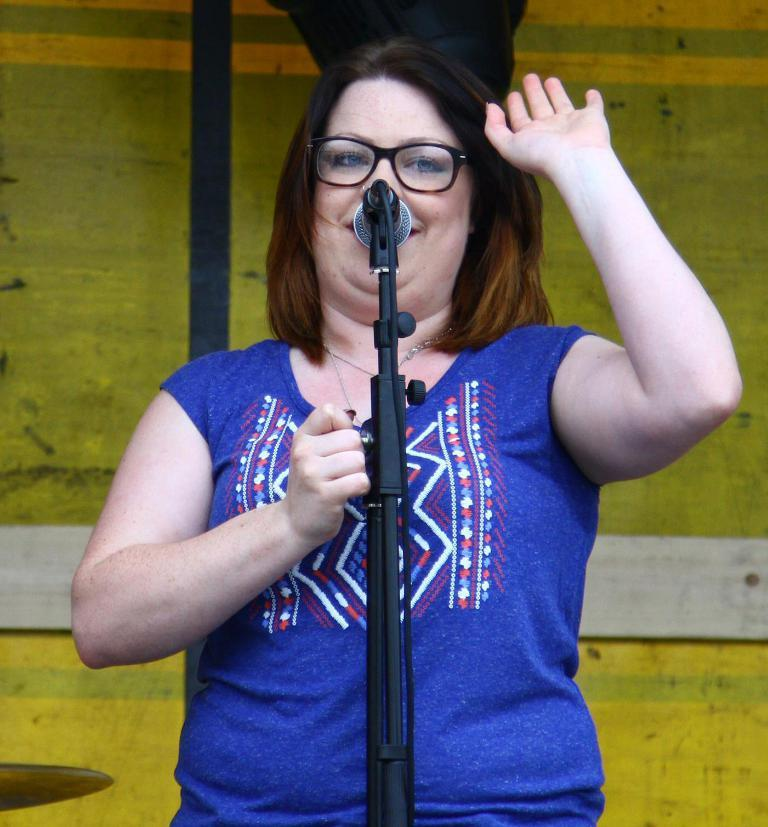Who is the main subject in the image? There is a woman in the image. What is the woman doing in the image? The woman is standing in front of a mic. What is the woman wearing in the image? The woman is wearing a blue color T-shirt and spectacles. What is the woman's facial expression in the image? The woman is smiling in the image. How much money is the woman holding in the image? There is no indication in the image that the woman is holding any money. Is the woman in jail in the image? There is no indication in the image that the woman is in jail. 